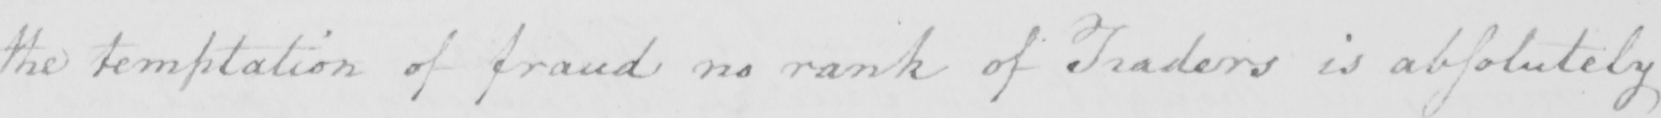Can you read and transcribe this handwriting? the temptation of fraud no rank of Traders is absolutely 